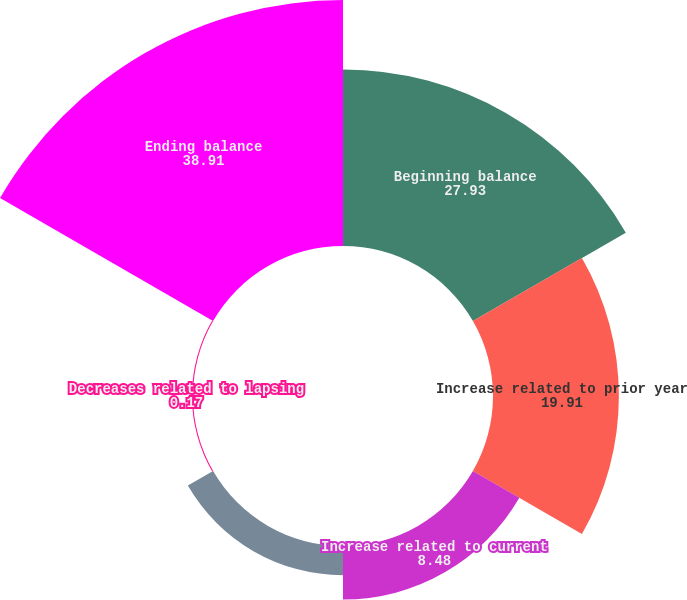<chart> <loc_0><loc_0><loc_500><loc_500><pie_chart><fcel>Beginning balance<fcel>Increase related to prior year<fcel>Increase related to current<fcel>Decrease related to current<fcel>Decreases related to lapsing<fcel>Ending balance<nl><fcel>27.93%<fcel>19.91%<fcel>8.48%<fcel>4.61%<fcel>0.17%<fcel>38.91%<nl></chart> 